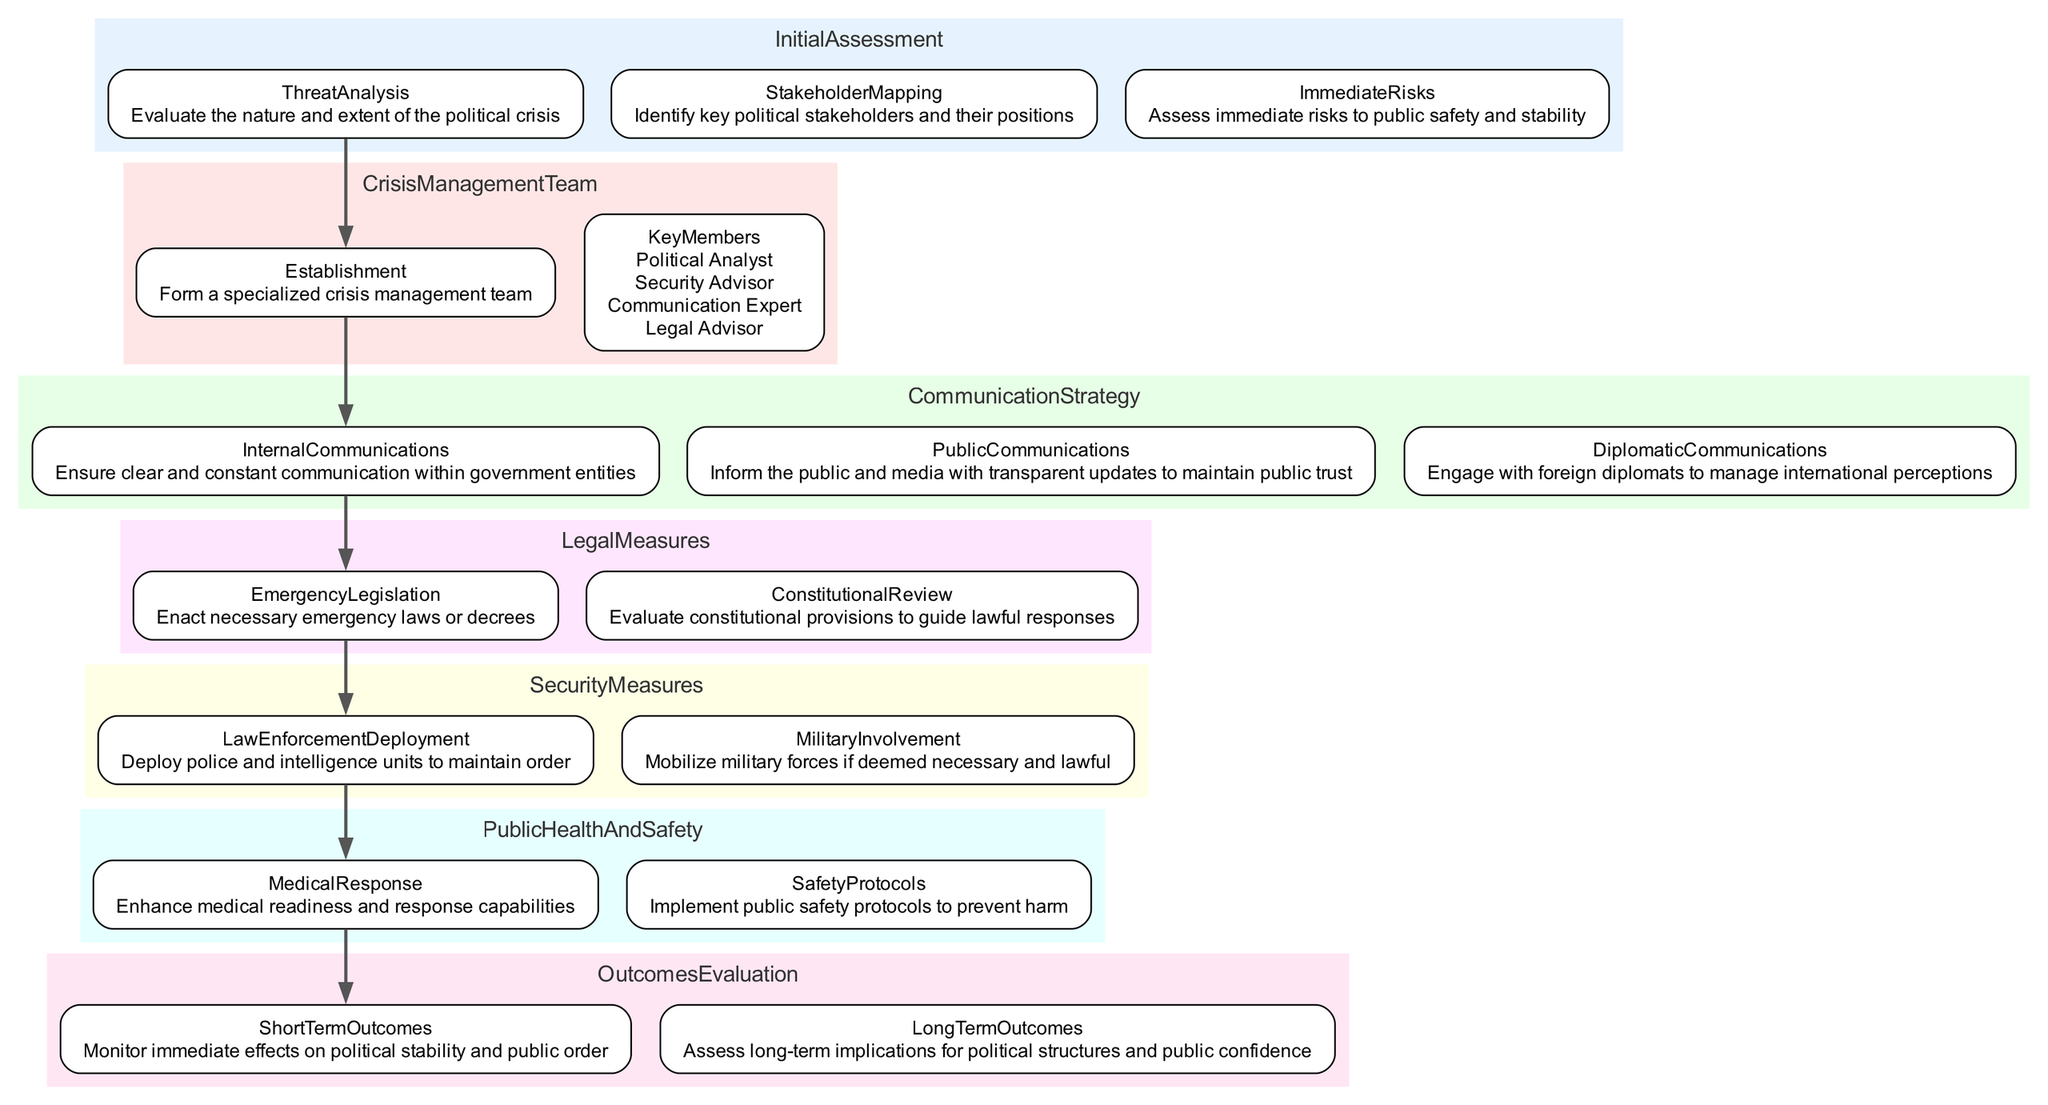What are the key members of the Crisis Management Team? The diagram lists the key members of the Crisis Management Team: Political Analyst, Security Advisor, Communication Expert, and Legal Advisor.
Answer: Political Analyst, Security Advisor, Communication Expert, Legal Advisor What is the first step in the Initial Assessment? The first step in the Initial Assessment category is Threat Analysis, which evaluates the nature and extent of the political crisis.
Answer: Threat Analysis How many stages are present in the Political Crisis Response Pathway? Upon analyzing the diagram, there are a total of six distinct stages in the Political Crisis Response Pathway: Initial Assessment, Crisis Management Team, Communication Strategy, Legal Measures, Security Measures, and Public Health and Safety.
Answer: 6 What follows the Communication Strategy in the pathway? The diagram indicates that after the Communication Strategy, the next stage is Legal Measures. This can be determined by tracing the flow from Communication Strategy to the subsequent node.
Answer: Legal Measures What are the Short Term Outcomes categorized under? The diagram specifies that the Short Term Outcomes are categorized under Outcomes Evaluation, which involves monitoring immediate effects on political stability and public order.
Answer: Outcomes Evaluation What kind of risks does the Immediate Risks assessment evaluate? Immediate Risks assessment evaluates the risks to public safety and stability during a political crisis, as indicated in the Initial Assessment stage of the diagram.
Answer: Public safety and stability What is the purpose of the Medical Response measure? The diagram describes the Medical Response as aiming to enhance medical readiness and response capabilities, addressing the public health implications during a political crisis.
Answer: Enhance medical readiness What type of communications are included in the Communication Strategy? The Communication Strategy includes three types of communications: Internal Communications, Public Communications, and Diplomatic Communications, as specified in the relevant section of the diagram.
Answer: Internal Communications, Public Communications, Diplomatic Communications How are Long Term Outcomes assessed? Long Term Outcomes are assessed through evaluating the long-term implications for political structures and public confidence, as stated in the Outcomes Evaluation section of the diagram.
Answer: Evaluating long-term implications 